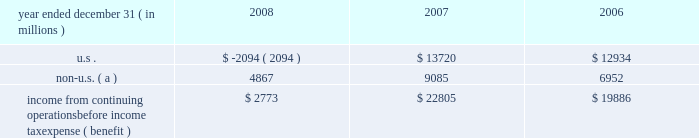Jpmorgan chase & co .
/ 2008 annual report 211 jpmorgan chase is subject to ongoing tax examinations by the tax authorities of the various jurisdictions in which it operates , including u.s .
Federal and state and non-u.s .
Jurisdictions .
The firm 2019s consoli- dated federal income tax returns are presently under examination by the internal revenue service ( 201cirs 201d ) for the years 2003 , 2004 and 2005 .
The consolidated federal income tax returns of bank one corporation , which merged with and into jpmorgan chase on july 1 , 2004 , are under examination for the years 2000 through 2003 , and for the period january 1 , 2004 , through july 1 , 2004 .
The consolidat- ed federal income tax returns of bear stearns for the years ended november 30 , 2003 , 2004 and 2005 , are also under examination .
All three examinations are expected to conclude in 2009 .
The irs audits of the consolidated federal income tax returns of jpmorgan chase for the years 2006 and 2007 , and for bear stearns for the years ended november 30 , 2006 and 2007 , are expected to commence in 2009 .
Administrative appeals are pending with the irs relating to prior examination periods .
For 2002 and prior years , refund claims relating to income and credit adjustments , and to tax attribute carry- backs , for jpmorgan chase and its predecessor entities , including bank one , have been filed .
Amended returns to reflect refund claims primarily attributable to net operating losses and tax credit carry- backs will be filed for the final bear stearns federal consolidated tax return for the period december 1 , 2007 , through may 30 , 2008 , and for prior years .
The table presents the u.s .
And non-u.s .
Components of income from continuing operations before income tax expense ( benefit ) . .
Non-u.s. ( a ) 4867 9085 6952 income from continuing operations before income tax expense ( benefit ) $ 2773 $ 22805 $ 19886 ( a ) for purposes of this table , non-u.s .
Income is defined as income generated from operations located outside the u.s .
Note 29 2013 restrictions on cash and intercom- pany funds transfers the business of jpmorgan chase bank , national association ( 201cjpmorgan chase bank , n.a . 201d ) is subject to examination and regula- tion by the office of the comptroller of the currency ( 201cocc 201d ) .
The bank is a member of the u.s .
Federal reserve system , and its deposits are insured by the fdic as discussed in note 20 on page 202 of this annual report .
The board of governors of the federal reserve system ( the 201cfederal reserve 201d ) requires depository institutions to maintain cash reserves with a federal reserve bank .
The average amount of reserve bal- ances deposited by the firm 2019s bank subsidiaries with various federal reserve banks was approximately $ 1.6 billion in 2008 and 2007 .
Restrictions imposed by u.s .
Federal law prohibit jpmorgan chase and certain of its affiliates from borrowing from banking subsidiaries unless the loans are secured in specified amounts .
Such secured loans to the firm or to other affiliates are generally limited to 10% ( 10 % ) of the banking subsidiary 2019s total capital , as determined by the risk- based capital guidelines ; the aggregate amount of all such loans is limited to 20% ( 20 % ) of the banking subsidiary 2019s total capital .
The principal sources of jpmorgan chase 2019s income ( on a parent com- pany 2013only basis ) are dividends and interest from jpmorgan chase bank , n.a. , and the other banking and nonbanking subsidiaries of jpmorgan chase .
In addition to dividend restrictions set forth in statutes and regulations , the federal reserve , the occ and the fdic have authority under the financial institutions supervisory act to pro- hibit or to limit the payment of dividends by the banking organizations they supervise , including jpmorgan chase and its subsidiaries that are banks or bank holding companies , if , in the banking regulator 2019s opin- ion , payment of a dividend would constitute an unsafe or unsound practice in light of the financial condition of the banking organization .
At january 1 , 2009 and 2008 , jpmorgan chase 2019s banking sub- sidiaries could pay , in the aggregate , $ 17.0 billion and $ 16.2 billion , respectively , in dividends to their respective bank holding companies without the prior approval of their relevant banking regulators .
The capacity to pay dividends in 2009 will be supplemented by the bank- ing subsidiaries 2019 earnings during the year .
In compliance with rules and regulations established by u.s .
And non-u.s .
Regulators , as of december 31 , 2008 and 2007 , cash in the amount of $ 20.8 billion and $ 16.0 billion , respectively , and securities with a fair value of $ 12.1 billion and $ 3.4 billion , respectively , were segregated in special bank accounts for the benefit of securities and futures brokerage customers. .
In 2007 what was the percent of the income from continuing operations that was from the us? 
Computations: (13720 / 22805)
Answer: 0.60162. 